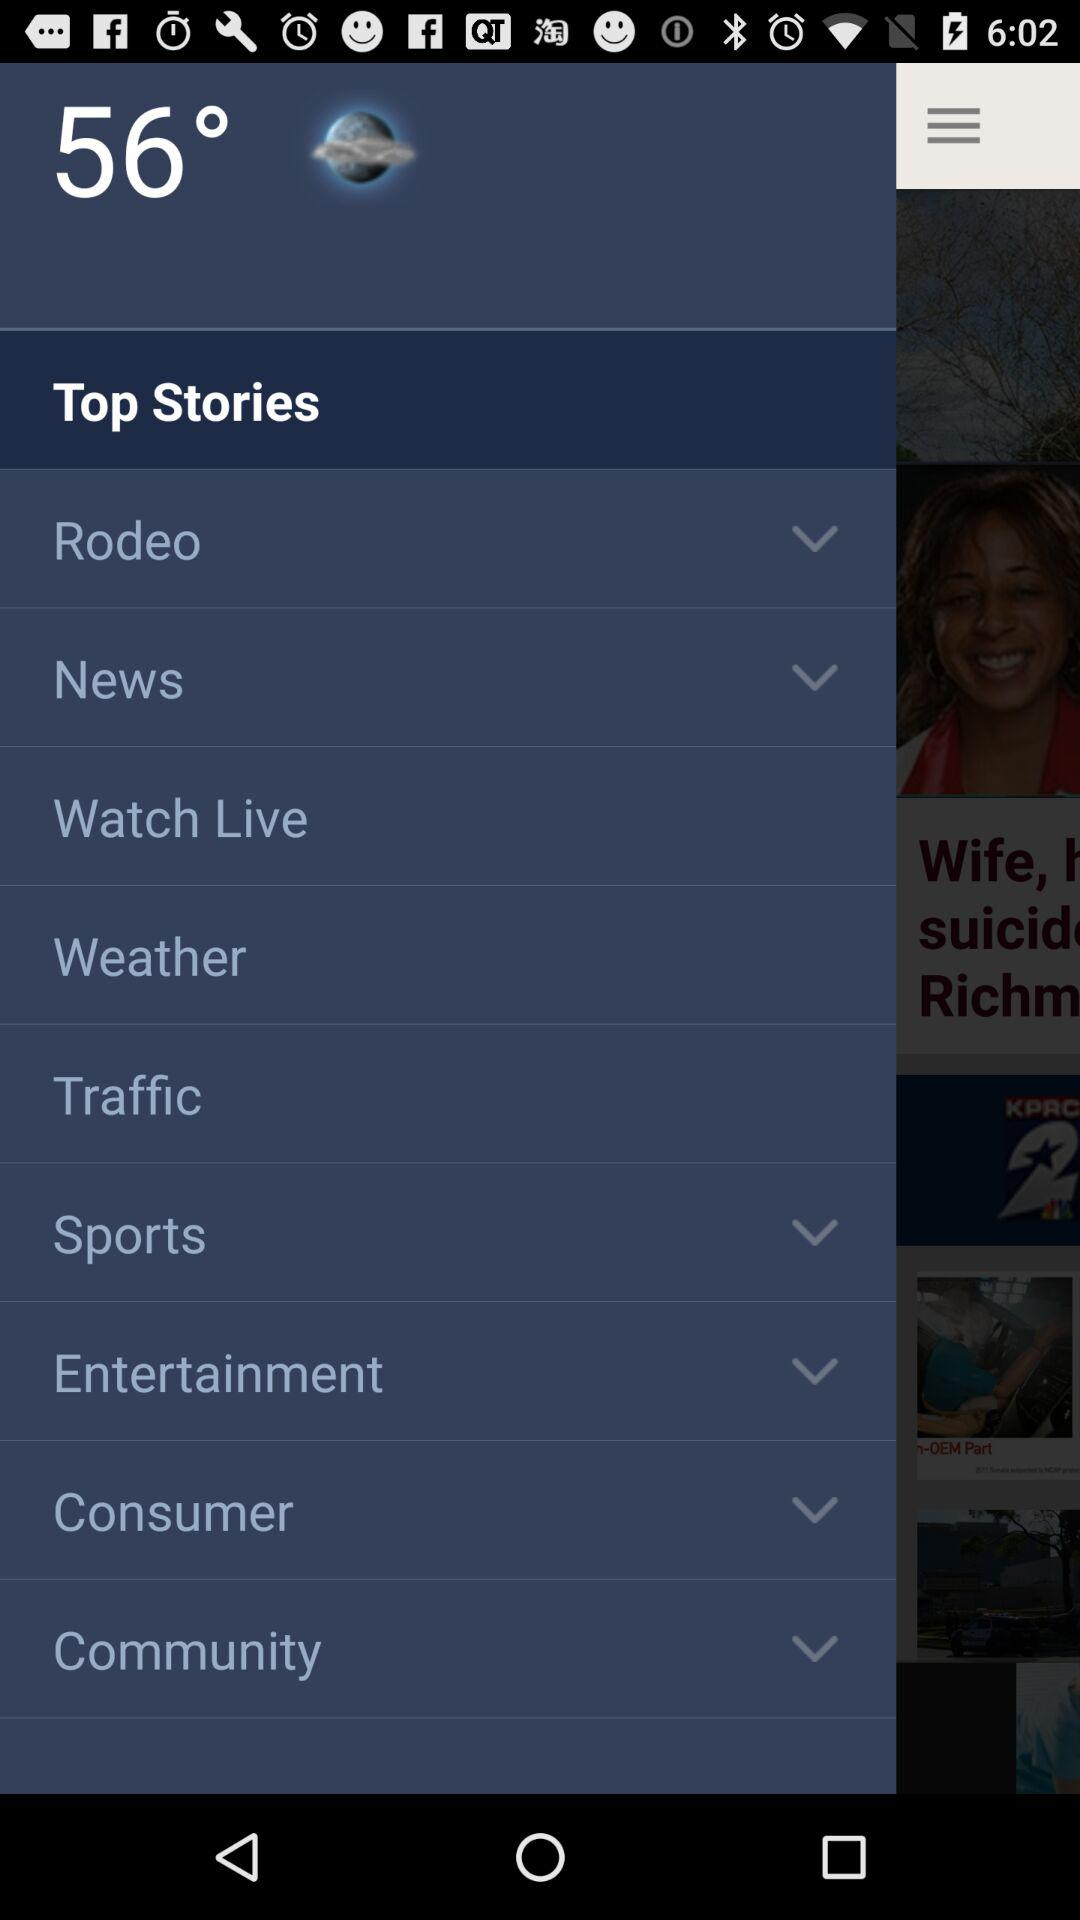How many notifications are there in "Traffic"?
When the provided information is insufficient, respond with <no answer>. <no answer> 